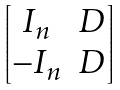<formula> <loc_0><loc_0><loc_500><loc_500>\begin{bmatrix} I _ { n } & D \\ - I _ { n } & D \end{bmatrix}</formula> 